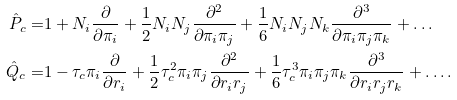Convert formula to latex. <formula><loc_0><loc_0><loc_500><loc_500>\hat { P } _ { c } = & 1 + N _ { i } \frac { \partial } { \partial \pi _ { i } } + \frac { 1 } { 2 } N _ { i } N _ { j } \frac { \partial ^ { 2 } } { \partial \pi _ { i } \pi _ { j } } + \frac { 1 } { 6 } N _ { i } N _ { j } N _ { k } \frac { \partial ^ { 3 } } { \partial \pi _ { i } \pi _ { j } \pi _ { k } } + \dots \\ \hat { Q } _ { c } = & 1 - \tau _ { c } \pi _ { i } \frac { \partial } { \partial r _ { i } } + \frac { 1 } { 2 } \tau _ { c } ^ { 2 } \pi _ { i } \pi _ { j } \frac { \partial ^ { 2 } } { \partial r _ { i } r _ { j } } + \frac { 1 } { 6 } \tau _ { c } ^ { 3 } \pi _ { i } \pi _ { j } \pi _ { k } \frac { \partial ^ { 3 } } { \partial r _ { i } r _ { j } r _ { k } } + \dots .</formula> 